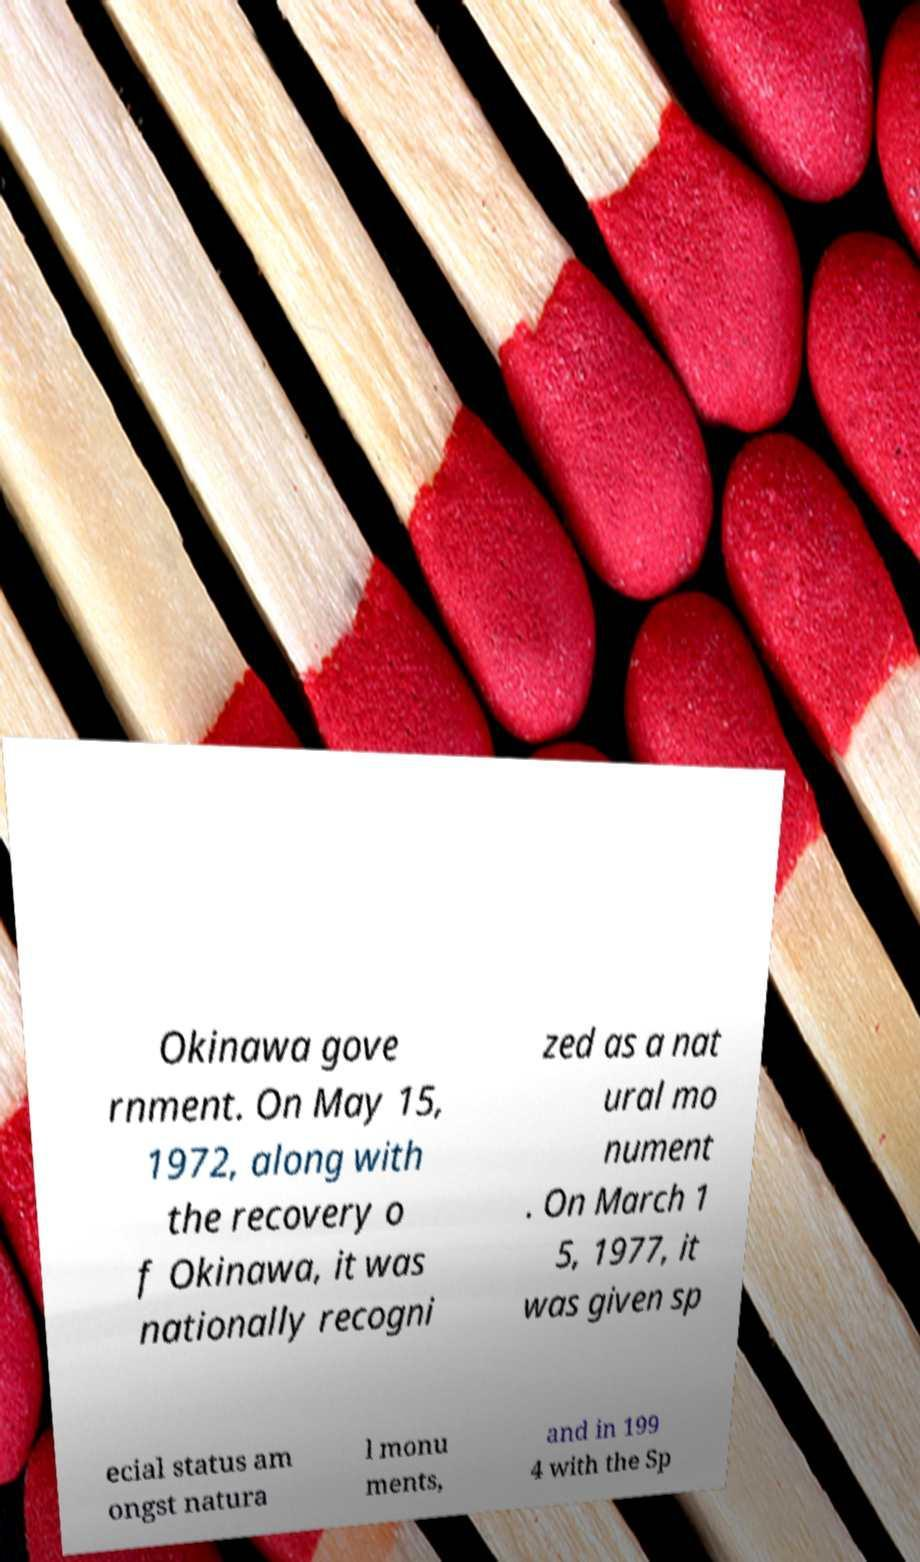For documentation purposes, I need the text within this image transcribed. Could you provide that? Okinawa gove rnment. On May 15, 1972, along with the recovery o f Okinawa, it was nationally recogni zed as a nat ural mo nument . On March 1 5, 1977, it was given sp ecial status am ongst natura l monu ments, and in 199 4 with the Sp 